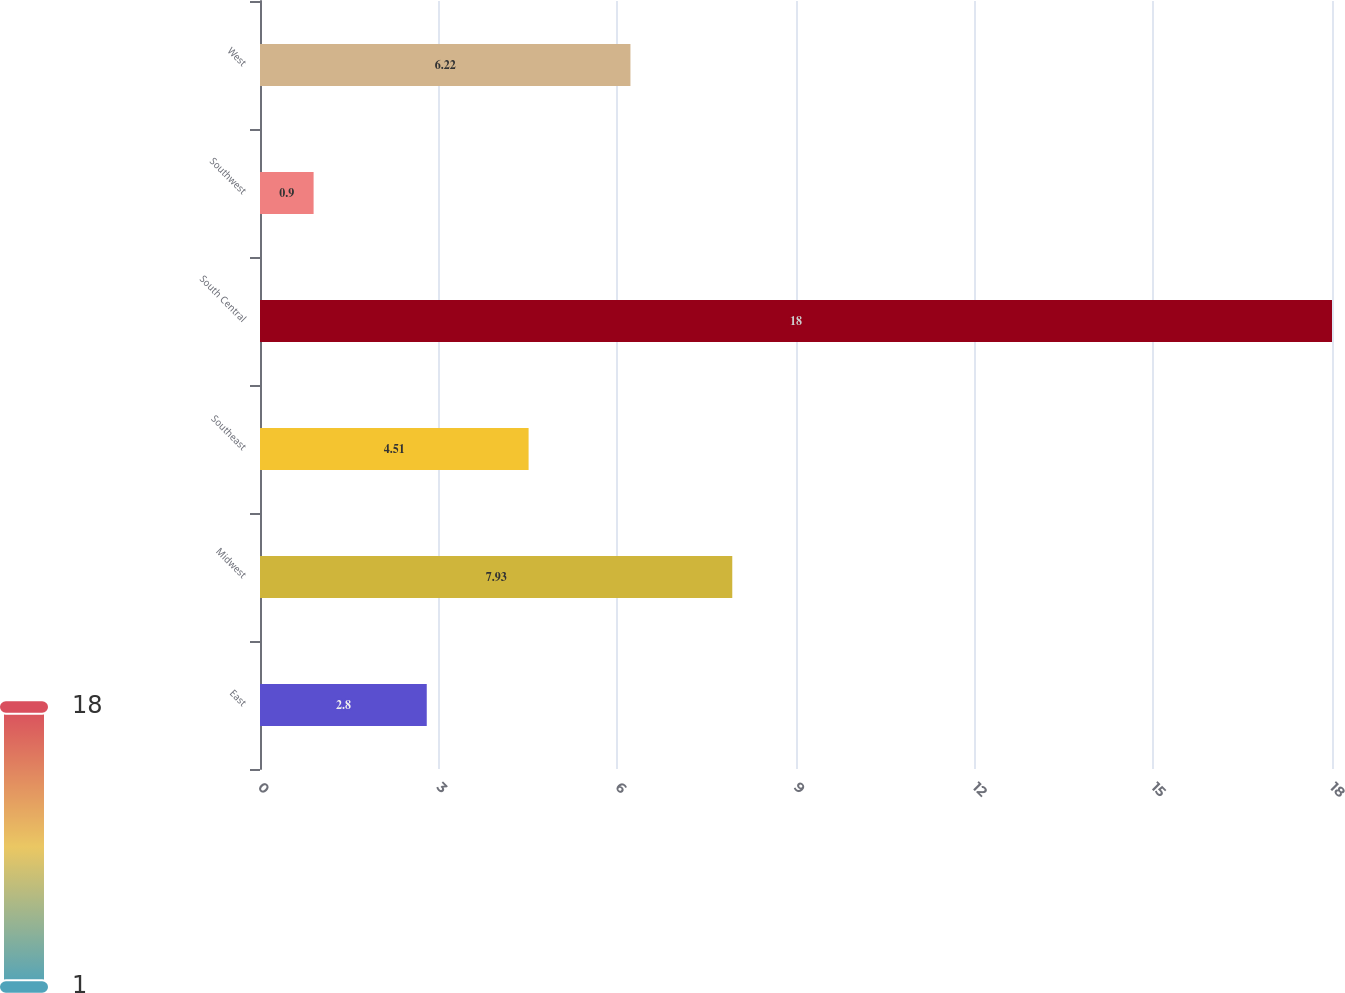Convert chart to OTSL. <chart><loc_0><loc_0><loc_500><loc_500><bar_chart><fcel>East<fcel>Midwest<fcel>Southeast<fcel>South Central<fcel>Southwest<fcel>West<nl><fcel>2.8<fcel>7.93<fcel>4.51<fcel>18<fcel>0.9<fcel>6.22<nl></chart> 